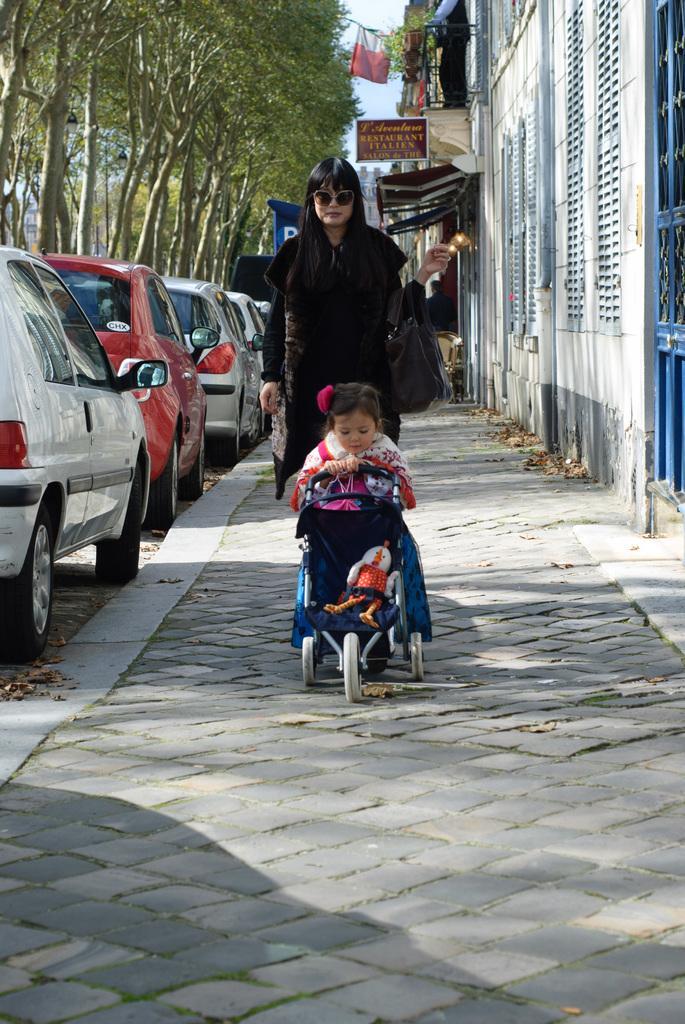Describe this image in one or two sentences. In this image I can see a woman and a kid with a toy in a cart on a pavement. On the left hand side of the image I can see some cars parked. I can see some trees. I can see buildings on the right hand side of the image with some sign boards. 